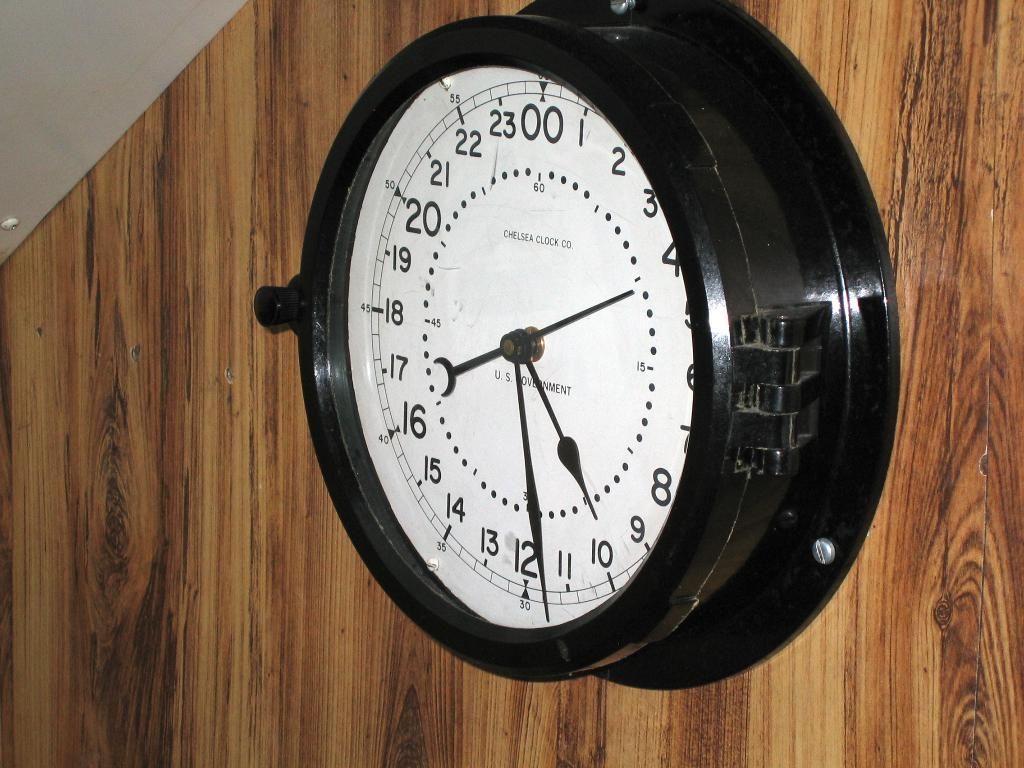<image>
Share a concise interpretation of the image provided. A large black clock on a wooden wall with the big hand pointing at the 10 and little hand between the 12 and 11. 